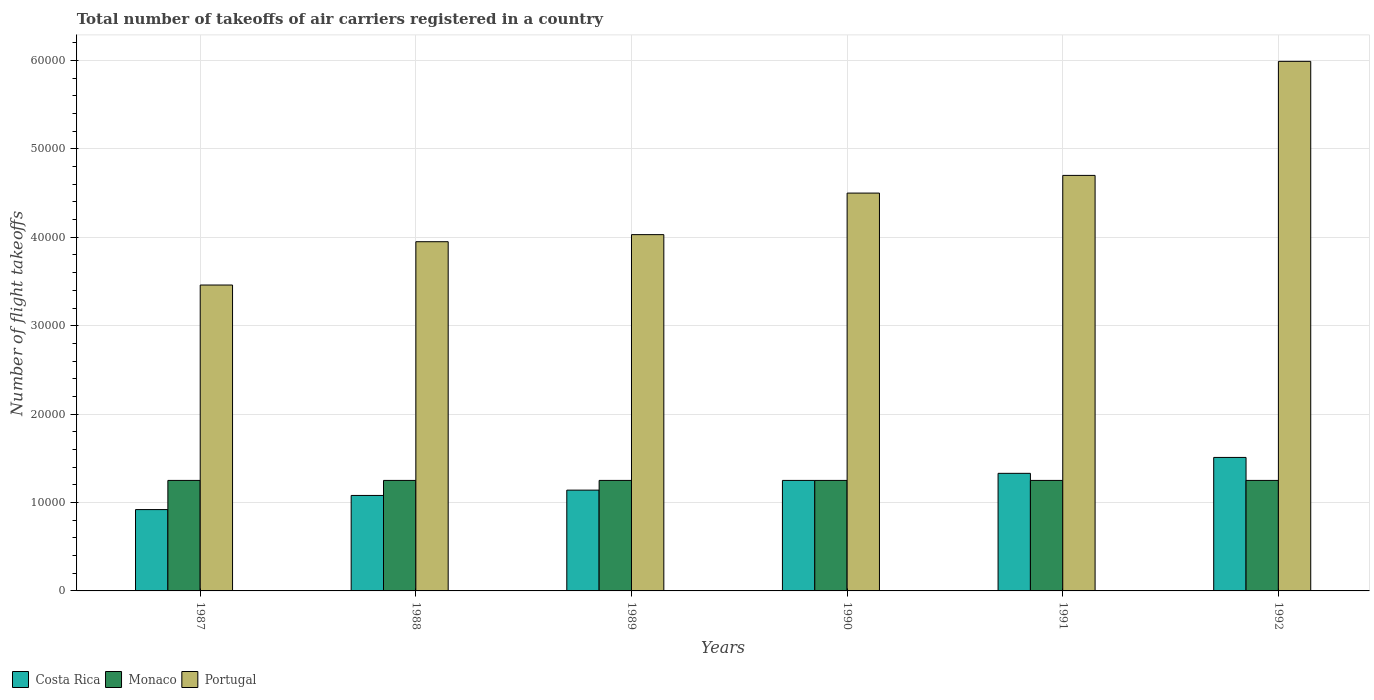How many groups of bars are there?
Offer a very short reply. 6. Are the number of bars per tick equal to the number of legend labels?
Offer a very short reply. Yes. Are the number of bars on each tick of the X-axis equal?
Your response must be concise. Yes. How many bars are there on the 1st tick from the right?
Make the answer very short. 3. What is the label of the 5th group of bars from the left?
Provide a succinct answer. 1991. What is the total number of flight takeoffs in Portugal in 1991?
Your response must be concise. 4.70e+04. Across all years, what is the maximum total number of flight takeoffs in Portugal?
Provide a short and direct response. 5.99e+04. Across all years, what is the minimum total number of flight takeoffs in Monaco?
Make the answer very short. 1.25e+04. In which year was the total number of flight takeoffs in Portugal maximum?
Offer a terse response. 1992. In which year was the total number of flight takeoffs in Monaco minimum?
Your answer should be very brief. 1987. What is the total total number of flight takeoffs in Monaco in the graph?
Make the answer very short. 7.50e+04. What is the difference between the total number of flight takeoffs in Costa Rica in 1990 and that in 1992?
Give a very brief answer. -2600. What is the difference between the total number of flight takeoffs in Costa Rica in 1992 and the total number of flight takeoffs in Portugal in 1987?
Make the answer very short. -1.95e+04. What is the average total number of flight takeoffs in Costa Rica per year?
Ensure brevity in your answer.  1.20e+04. In the year 1987, what is the difference between the total number of flight takeoffs in Costa Rica and total number of flight takeoffs in Monaco?
Ensure brevity in your answer.  -3300. What is the ratio of the total number of flight takeoffs in Monaco in 1988 to that in 1990?
Your answer should be very brief. 1. Is the difference between the total number of flight takeoffs in Costa Rica in 1990 and 1992 greater than the difference between the total number of flight takeoffs in Monaco in 1990 and 1992?
Your answer should be compact. No. What is the difference between the highest and the second highest total number of flight takeoffs in Portugal?
Ensure brevity in your answer.  1.29e+04. In how many years, is the total number of flight takeoffs in Monaco greater than the average total number of flight takeoffs in Monaco taken over all years?
Ensure brevity in your answer.  0. What does the 1st bar from the left in 1989 represents?
Keep it short and to the point. Costa Rica. Is it the case that in every year, the sum of the total number of flight takeoffs in Monaco and total number of flight takeoffs in Portugal is greater than the total number of flight takeoffs in Costa Rica?
Give a very brief answer. Yes. What is the difference between two consecutive major ticks on the Y-axis?
Make the answer very short. 10000. Does the graph contain grids?
Ensure brevity in your answer.  Yes. Where does the legend appear in the graph?
Give a very brief answer. Bottom left. What is the title of the graph?
Offer a terse response. Total number of takeoffs of air carriers registered in a country. What is the label or title of the X-axis?
Offer a very short reply. Years. What is the label or title of the Y-axis?
Give a very brief answer. Number of flight takeoffs. What is the Number of flight takeoffs in Costa Rica in 1987?
Offer a very short reply. 9200. What is the Number of flight takeoffs in Monaco in 1987?
Your answer should be compact. 1.25e+04. What is the Number of flight takeoffs in Portugal in 1987?
Provide a short and direct response. 3.46e+04. What is the Number of flight takeoffs in Costa Rica in 1988?
Offer a terse response. 1.08e+04. What is the Number of flight takeoffs of Monaco in 1988?
Offer a terse response. 1.25e+04. What is the Number of flight takeoffs in Portugal in 1988?
Provide a succinct answer. 3.95e+04. What is the Number of flight takeoffs in Costa Rica in 1989?
Your response must be concise. 1.14e+04. What is the Number of flight takeoffs of Monaco in 1989?
Your answer should be compact. 1.25e+04. What is the Number of flight takeoffs in Portugal in 1989?
Keep it short and to the point. 4.03e+04. What is the Number of flight takeoffs in Costa Rica in 1990?
Provide a succinct answer. 1.25e+04. What is the Number of flight takeoffs in Monaco in 1990?
Offer a very short reply. 1.25e+04. What is the Number of flight takeoffs in Portugal in 1990?
Offer a terse response. 4.50e+04. What is the Number of flight takeoffs of Costa Rica in 1991?
Offer a terse response. 1.33e+04. What is the Number of flight takeoffs in Monaco in 1991?
Offer a very short reply. 1.25e+04. What is the Number of flight takeoffs of Portugal in 1991?
Provide a succinct answer. 4.70e+04. What is the Number of flight takeoffs of Costa Rica in 1992?
Offer a very short reply. 1.51e+04. What is the Number of flight takeoffs of Monaco in 1992?
Offer a very short reply. 1.25e+04. What is the Number of flight takeoffs of Portugal in 1992?
Give a very brief answer. 5.99e+04. Across all years, what is the maximum Number of flight takeoffs in Costa Rica?
Give a very brief answer. 1.51e+04. Across all years, what is the maximum Number of flight takeoffs in Monaco?
Provide a succinct answer. 1.25e+04. Across all years, what is the maximum Number of flight takeoffs of Portugal?
Your answer should be very brief. 5.99e+04. Across all years, what is the minimum Number of flight takeoffs of Costa Rica?
Keep it short and to the point. 9200. Across all years, what is the minimum Number of flight takeoffs of Monaco?
Your answer should be very brief. 1.25e+04. Across all years, what is the minimum Number of flight takeoffs of Portugal?
Your answer should be compact. 3.46e+04. What is the total Number of flight takeoffs of Costa Rica in the graph?
Provide a short and direct response. 7.23e+04. What is the total Number of flight takeoffs of Monaco in the graph?
Offer a very short reply. 7.50e+04. What is the total Number of flight takeoffs of Portugal in the graph?
Offer a very short reply. 2.66e+05. What is the difference between the Number of flight takeoffs in Costa Rica in 1987 and that in 1988?
Provide a short and direct response. -1600. What is the difference between the Number of flight takeoffs of Portugal in 1987 and that in 1988?
Offer a very short reply. -4900. What is the difference between the Number of flight takeoffs of Costa Rica in 1987 and that in 1989?
Give a very brief answer. -2200. What is the difference between the Number of flight takeoffs of Portugal in 1987 and that in 1989?
Your answer should be compact. -5700. What is the difference between the Number of flight takeoffs of Costa Rica in 1987 and that in 1990?
Your answer should be very brief. -3300. What is the difference between the Number of flight takeoffs in Monaco in 1987 and that in 1990?
Your answer should be very brief. 0. What is the difference between the Number of flight takeoffs in Portugal in 1987 and that in 1990?
Your answer should be very brief. -1.04e+04. What is the difference between the Number of flight takeoffs in Costa Rica in 1987 and that in 1991?
Your response must be concise. -4100. What is the difference between the Number of flight takeoffs in Portugal in 1987 and that in 1991?
Give a very brief answer. -1.24e+04. What is the difference between the Number of flight takeoffs of Costa Rica in 1987 and that in 1992?
Your answer should be compact. -5900. What is the difference between the Number of flight takeoffs in Monaco in 1987 and that in 1992?
Make the answer very short. 0. What is the difference between the Number of flight takeoffs of Portugal in 1987 and that in 1992?
Offer a very short reply. -2.53e+04. What is the difference between the Number of flight takeoffs in Costa Rica in 1988 and that in 1989?
Provide a short and direct response. -600. What is the difference between the Number of flight takeoffs of Portugal in 1988 and that in 1989?
Your answer should be very brief. -800. What is the difference between the Number of flight takeoffs in Costa Rica in 1988 and that in 1990?
Offer a very short reply. -1700. What is the difference between the Number of flight takeoffs of Portugal in 1988 and that in 1990?
Your answer should be very brief. -5500. What is the difference between the Number of flight takeoffs in Costa Rica in 1988 and that in 1991?
Ensure brevity in your answer.  -2500. What is the difference between the Number of flight takeoffs of Monaco in 1988 and that in 1991?
Your answer should be compact. 0. What is the difference between the Number of flight takeoffs in Portugal in 1988 and that in 1991?
Give a very brief answer. -7500. What is the difference between the Number of flight takeoffs of Costa Rica in 1988 and that in 1992?
Your response must be concise. -4300. What is the difference between the Number of flight takeoffs of Portugal in 1988 and that in 1992?
Provide a succinct answer. -2.04e+04. What is the difference between the Number of flight takeoffs in Costa Rica in 1989 and that in 1990?
Offer a very short reply. -1100. What is the difference between the Number of flight takeoffs of Portugal in 1989 and that in 1990?
Offer a terse response. -4700. What is the difference between the Number of flight takeoffs in Costa Rica in 1989 and that in 1991?
Your answer should be very brief. -1900. What is the difference between the Number of flight takeoffs in Portugal in 1989 and that in 1991?
Provide a short and direct response. -6700. What is the difference between the Number of flight takeoffs of Costa Rica in 1989 and that in 1992?
Keep it short and to the point. -3700. What is the difference between the Number of flight takeoffs in Portugal in 1989 and that in 1992?
Ensure brevity in your answer.  -1.96e+04. What is the difference between the Number of flight takeoffs in Costa Rica in 1990 and that in 1991?
Your answer should be very brief. -800. What is the difference between the Number of flight takeoffs of Portugal in 1990 and that in 1991?
Provide a succinct answer. -2000. What is the difference between the Number of flight takeoffs in Costa Rica in 1990 and that in 1992?
Offer a very short reply. -2600. What is the difference between the Number of flight takeoffs of Monaco in 1990 and that in 1992?
Make the answer very short. 0. What is the difference between the Number of flight takeoffs of Portugal in 1990 and that in 1992?
Offer a very short reply. -1.49e+04. What is the difference between the Number of flight takeoffs in Costa Rica in 1991 and that in 1992?
Offer a very short reply. -1800. What is the difference between the Number of flight takeoffs of Portugal in 1991 and that in 1992?
Provide a short and direct response. -1.29e+04. What is the difference between the Number of flight takeoffs in Costa Rica in 1987 and the Number of flight takeoffs in Monaco in 1988?
Provide a short and direct response. -3300. What is the difference between the Number of flight takeoffs in Costa Rica in 1987 and the Number of flight takeoffs in Portugal in 1988?
Offer a terse response. -3.03e+04. What is the difference between the Number of flight takeoffs of Monaco in 1987 and the Number of flight takeoffs of Portugal in 1988?
Ensure brevity in your answer.  -2.70e+04. What is the difference between the Number of flight takeoffs of Costa Rica in 1987 and the Number of flight takeoffs of Monaco in 1989?
Give a very brief answer. -3300. What is the difference between the Number of flight takeoffs in Costa Rica in 1987 and the Number of flight takeoffs in Portugal in 1989?
Offer a very short reply. -3.11e+04. What is the difference between the Number of flight takeoffs in Monaco in 1987 and the Number of flight takeoffs in Portugal in 1989?
Provide a succinct answer. -2.78e+04. What is the difference between the Number of flight takeoffs in Costa Rica in 1987 and the Number of flight takeoffs in Monaco in 1990?
Provide a succinct answer. -3300. What is the difference between the Number of flight takeoffs of Costa Rica in 1987 and the Number of flight takeoffs of Portugal in 1990?
Keep it short and to the point. -3.58e+04. What is the difference between the Number of flight takeoffs of Monaco in 1987 and the Number of flight takeoffs of Portugal in 1990?
Provide a succinct answer. -3.25e+04. What is the difference between the Number of flight takeoffs of Costa Rica in 1987 and the Number of flight takeoffs of Monaco in 1991?
Your answer should be compact. -3300. What is the difference between the Number of flight takeoffs of Costa Rica in 1987 and the Number of flight takeoffs of Portugal in 1991?
Offer a terse response. -3.78e+04. What is the difference between the Number of flight takeoffs of Monaco in 1987 and the Number of flight takeoffs of Portugal in 1991?
Provide a succinct answer. -3.45e+04. What is the difference between the Number of flight takeoffs in Costa Rica in 1987 and the Number of flight takeoffs in Monaco in 1992?
Offer a very short reply. -3300. What is the difference between the Number of flight takeoffs in Costa Rica in 1987 and the Number of flight takeoffs in Portugal in 1992?
Provide a succinct answer. -5.07e+04. What is the difference between the Number of flight takeoffs in Monaco in 1987 and the Number of flight takeoffs in Portugal in 1992?
Offer a terse response. -4.74e+04. What is the difference between the Number of flight takeoffs of Costa Rica in 1988 and the Number of flight takeoffs of Monaco in 1989?
Your answer should be compact. -1700. What is the difference between the Number of flight takeoffs of Costa Rica in 1988 and the Number of flight takeoffs of Portugal in 1989?
Provide a short and direct response. -2.95e+04. What is the difference between the Number of flight takeoffs of Monaco in 1988 and the Number of flight takeoffs of Portugal in 1989?
Give a very brief answer. -2.78e+04. What is the difference between the Number of flight takeoffs in Costa Rica in 1988 and the Number of flight takeoffs in Monaco in 1990?
Your answer should be very brief. -1700. What is the difference between the Number of flight takeoffs of Costa Rica in 1988 and the Number of flight takeoffs of Portugal in 1990?
Provide a succinct answer. -3.42e+04. What is the difference between the Number of flight takeoffs in Monaco in 1988 and the Number of flight takeoffs in Portugal in 1990?
Offer a very short reply. -3.25e+04. What is the difference between the Number of flight takeoffs of Costa Rica in 1988 and the Number of flight takeoffs of Monaco in 1991?
Make the answer very short. -1700. What is the difference between the Number of flight takeoffs of Costa Rica in 1988 and the Number of flight takeoffs of Portugal in 1991?
Give a very brief answer. -3.62e+04. What is the difference between the Number of flight takeoffs of Monaco in 1988 and the Number of flight takeoffs of Portugal in 1991?
Give a very brief answer. -3.45e+04. What is the difference between the Number of flight takeoffs of Costa Rica in 1988 and the Number of flight takeoffs of Monaco in 1992?
Provide a short and direct response. -1700. What is the difference between the Number of flight takeoffs in Costa Rica in 1988 and the Number of flight takeoffs in Portugal in 1992?
Make the answer very short. -4.91e+04. What is the difference between the Number of flight takeoffs of Monaco in 1988 and the Number of flight takeoffs of Portugal in 1992?
Provide a succinct answer. -4.74e+04. What is the difference between the Number of flight takeoffs of Costa Rica in 1989 and the Number of flight takeoffs of Monaco in 1990?
Keep it short and to the point. -1100. What is the difference between the Number of flight takeoffs of Costa Rica in 1989 and the Number of flight takeoffs of Portugal in 1990?
Your answer should be very brief. -3.36e+04. What is the difference between the Number of flight takeoffs of Monaco in 1989 and the Number of flight takeoffs of Portugal in 1990?
Keep it short and to the point. -3.25e+04. What is the difference between the Number of flight takeoffs in Costa Rica in 1989 and the Number of flight takeoffs in Monaco in 1991?
Offer a terse response. -1100. What is the difference between the Number of flight takeoffs in Costa Rica in 1989 and the Number of flight takeoffs in Portugal in 1991?
Keep it short and to the point. -3.56e+04. What is the difference between the Number of flight takeoffs in Monaco in 1989 and the Number of flight takeoffs in Portugal in 1991?
Your response must be concise. -3.45e+04. What is the difference between the Number of flight takeoffs in Costa Rica in 1989 and the Number of flight takeoffs in Monaco in 1992?
Provide a succinct answer. -1100. What is the difference between the Number of flight takeoffs of Costa Rica in 1989 and the Number of flight takeoffs of Portugal in 1992?
Keep it short and to the point. -4.85e+04. What is the difference between the Number of flight takeoffs of Monaco in 1989 and the Number of flight takeoffs of Portugal in 1992?
Provide a succinct answer. -4.74e+04. What is the difference between the Number of flight takeoffs of Costa Rica in 1990 and the Number of flight takeoffs of Portugal in 1991?
Offer a very short reply. -3.45e+04. What is the difference between the Number of flight takeoffs in Monaco in 1990 and the Number of flight takeoffs in Portugal in 1991?
Give a very brief answer. -3.45e+04. What is the difference between the Number of flight takeoffs of Costa Rica in 1990 and the Number of flight takeoffs of Portugal in 1992?
Provide a short and direct response. -4.74e+04. What is the difference between the Number of flight takeoffs of Monaco in 1990 and the Number of flight takeoffs of Portugal in 1992?
Offer a very short reply. -4.74e+04. What is the difference between the Number of flight takeoffs in Costa Rica in 1991 and the Number of flight takeoffs in Monaco in 1992?
Keep it short and to the point. 800. What is the difference between the Number of flight takeoffs in Costa Rica in 1991 and the Number of flight takeoffs in Portugal in 1992?
Make the answer very short. -4.66e+04. What is the difference between the Number of flight takeoffs in Monaco in 1991 and the Number of flight takeoffs in Portugal in 1992?
Your answer should be compact. -4.74e+04. What is the average Number of flight takeoffs of Costa Rica per year?
Ensure brevity in your answer.  1.20e+04. What is the average Number of flight takeoffs of Monaco per year?
Give a very brief answer. 1.25e+04. What is the average Number of flight takeoffs of Portugal per year?
Provide a succinct answer. 4.44e+04. In the year 1987, what is the difference between the Number of flight takeoffs of Costa Rica and Number of flight takeoffs of Monaco?
Keep it short and to the point. -3300. In the year 1987, what is the difference between the Number of flight takeoffs of Costa Rica and Number of flight takeoffs of Portugal?
Give a very brief answer. -2.54e+04. In the year 1987, what is the difference between the Number of flight takeoffs in Monaco and Number of flight takeoffs in Portugal?
Make the answer very short. -2.21e+04. In the year 1988, what is the difference between the Number of flight takeoffs in Costa Rica and Number of flight takeoffs in Monaco?
Provide a short and direct response. -1700. In the year 1988, what is the difference between the Number of flight takeoffs in Costa Rica and Number of flight takeoffs in Portugal?
Ensure brevity in your answer.  -2.87e+04. In the year 1988, what is the difference between the Number of flight takeoffs in Monaco and Number of flight takeoffs in Portugal?
Ensure brevity in your answer.  -2.70e+04. In the year 1989, what is the difference between the Number of flight takeoffs of Costa Rica and Number of flight takeoffs of Monaco?
Provide a succinct answer. -1100. In the year 1989, what is the difference between the Number of flight takeoffs of Costa Rica and Number of flight takeoffs of Portugal?
Your answer should be compact. -2.89e+04. In the year 1989, what is the difference between the Number of flight takeoffs of Monaco and Number of flight takeoffs of Portugal?
Give a very brief answer. -2.78e+04. In the year 1990, what is the difference between the Number of flight takeoffs in Costa Rica and Number of flight takeoffs in Portugal?
Ensure brevity in your answer.  -3.25e+04. In the year 1990, what is the difference between the Number of flight takeoffs in Monaco and Number of flight takeoffs in Portugal?
Keep it short and to the point. -3.25e+04. In the year 1991, what is the difference between the Number of flight takeoffs of Costa Rica and Number of flight takeoffs of Monaco?
Make the answer very short. 800. In the year 1991, what is the difference between the Number of flight takeoffs in Costa Rica and Number of flight takeoffs in Portugal?
Your response must be concise. -3.37e+04. In the year 1991, what is the difference between the Number of flight takeoffs of Monaco and Number of flight takeoffs of Portugal?
Your answer should be compact. -3.45e+04. In the year 1992, what is the difference between the Number of flight takeoffs of Costa Rica and Number of flight takeoffs of Monaco?
Offer a very short reply. 2600. In the year 1992, what is the difference between the Number of flight takeoffs of Costa Rica and Number of flight takeoffs of Portugal?
Offer a terse response. -4.48e+04. In the year 1992, what is the difference between the Number of flight takeoffs of Monaco and Number of flight takeoffs of Portugal?
Offer a very short reply. -4.74e+04. What is the ratio of the Number of flight takeoffs in Costa Rica in 1987 to that in 1988?
Provide a short and direct response. 0.85. What is the ratio of the Number of flight takeoffs in Monaco in 1987 to that in 1988?
Keep it short and to the point. 1. What is the ratio of the Number of flight takeoffs in Portugal in 1987 to that in 1988?
Provide a short and direct response. 0.88. What is the ratio of the Number of flight takeoffs in Costa Rica in 1987 to that in 1989?
Make the answer very short. 0.81. What is the ratio of the Number of flight takeoffs in Portugal in 1987 to that in 1989?
Offer a terse response. 0.86. What is the ratio of the Number of flight takeoffs in Costa Rica in 1987 to that in 1990?
Ensure brevity in your answer.  0.74. What is the ratio of the Number of flight takeoffs in Portugal in 1987 to that in 1990?
Make the answer very short. 0.77. What is the ratio of the Number of flight takeoffs in Costa Rica in 1987 to that in 1991?
Offer a terse response. 0.69. What is the ratio of the Number of flight takeoffs of Monaco in 1987 to that in 1991?
Provide a succinct answer. 1. What is the ratio of the Number of flight takeoffs of Portugal in 1987 to that in 1991?
Offer a very short reply. 0.74. What is the ratio of the Number of flight takeoffs of Costa Rica in 1987 to that in 1992?
Ensure brevity in your answer.  0.61. What is the ratio of the Number of flight takeoffs in Monaco in 1987 to that in 1992?
Offer a very short reply. 1. What is the ratio of the Number of flight takeoffs in Portugal in 1987 to that in 1992?
Your response must be concise. 0.58. What is the ratio of the Number of flight takeoffs of Monaco in 1988 to that in 1989?
Give a very brief answer. 1. What is the ratio of the Number of flight takeoffs in Portugal in 1988 to that in 1989?
Give a very brief answer. 0.98. What is the ratio of the Number of flight takeoffs in Costa Rica in 1988 to that in 1990?
Your response must be concise. 0.86. What is the ratio of the Number of flight takeoffs in Monaco in 1988 to that in 1990?
Give a very brief answer. 1. What is the ratio of the Number of flight takeoffs of Portugal in 1988 to that in 1990?
Your response must be concise. 0.88. What is the ratio of the Number of flight takeoffs in Costa Rica in 1988 to that in 1991?
Provide a short and direct response. 0.81. What is the ratio of the Number of flight takeoffs of Portugal in 1988 to that in 1991?
Ensure brevity in your answer.  0.84. What is the ratio of the Number of flight takeoffs of Costa Rica in 1988 to that in 1992?
Your answer should be very brief. 0.72. What is the ratio of the Number of flight takeoffs of Portugal in 1988 to that in 1992?
Your response must be concise. 0.66. What is the ratio of the Number of flight takeoffs of Costa Rica in 1989 to that in 1990?
Your response must be concise. 0.91. What is the ratio of the Number of flight takeoffs in Monaco in 1989 to that in 1990?
Make the answer very short. 1. What is the ratio of the Number of flight takeoffs of Portugal in 1989 to that in 1990?
Offer a terse response. 0.9. What is the ratio of the Number of flight takeoffs of Portugal in 1989 to that in 1991?
Give a very brief answer. 0.86. What is the ratio of the Number of flight takeoffs of Costa Rica in 1989 to that in 1992?
Your answer should be very brief. 0.76. What is the ratio of the Number of flight takeoffs of Monaco in 1989 to that in 1992?
Provide a succinct answer. 1. What is the ratio of the Number of flight takeoffs in Portugal in 1989 to that in 1992?
Offer a very short reply. 0.67. What is the ratio of the Number of flight takeoffs in Costa Rica in 1990 to that in 1991?
Ensure brevity in your answer.  0.94. What is the ratio of the Number of flight takeoffs in Portugal in 1990 to that in 1991?
Offer a terse response. 0.96. What is the ratio of the Number of flight takeoffs of Costa Rica in 1990 to that in 1992?
Give a very brief answer. 0.83. What is the ratio of the Number of flight takeoffs in Portugal in 1990 to that in 1992?
Offer a terse response. 0.75. What is the ratio of the Number of flight takeoffs in Costa Rica in 1991 to that in 1992?
Your answer should be very brief. 0.88. What is the ratio of the Number of flight takeoffs of Monaco in 1991 to that in 1992?
Your answer should be compact. 1. What is the ratio of the Number of flight takeoffs of Portugal in 1991 to that in 1992?
Give a very brief answer. 0.78. What is the difference between the highest and the second highest Number of flight takeoffs of Costa Rica?
Provide a succinct answer. 1800. What is the difference between the highest and the second highest Number of flight takeoffs of Portugal?
Your answer should be compact. 1.29e+04. What is the difference between the highest and the lowest Number of flight takeoffs of Costa Rica?
Your answer should be very brief. 5900. What is the difference between the highest and the lowest Number of flight takeoffs in Monaco?
Your answer should be very brief. 0. What is the difference between the highest and the lowest Number of flight takeoffs of Portugal?
Ensure brevity in your answer.  2.53e+04. 